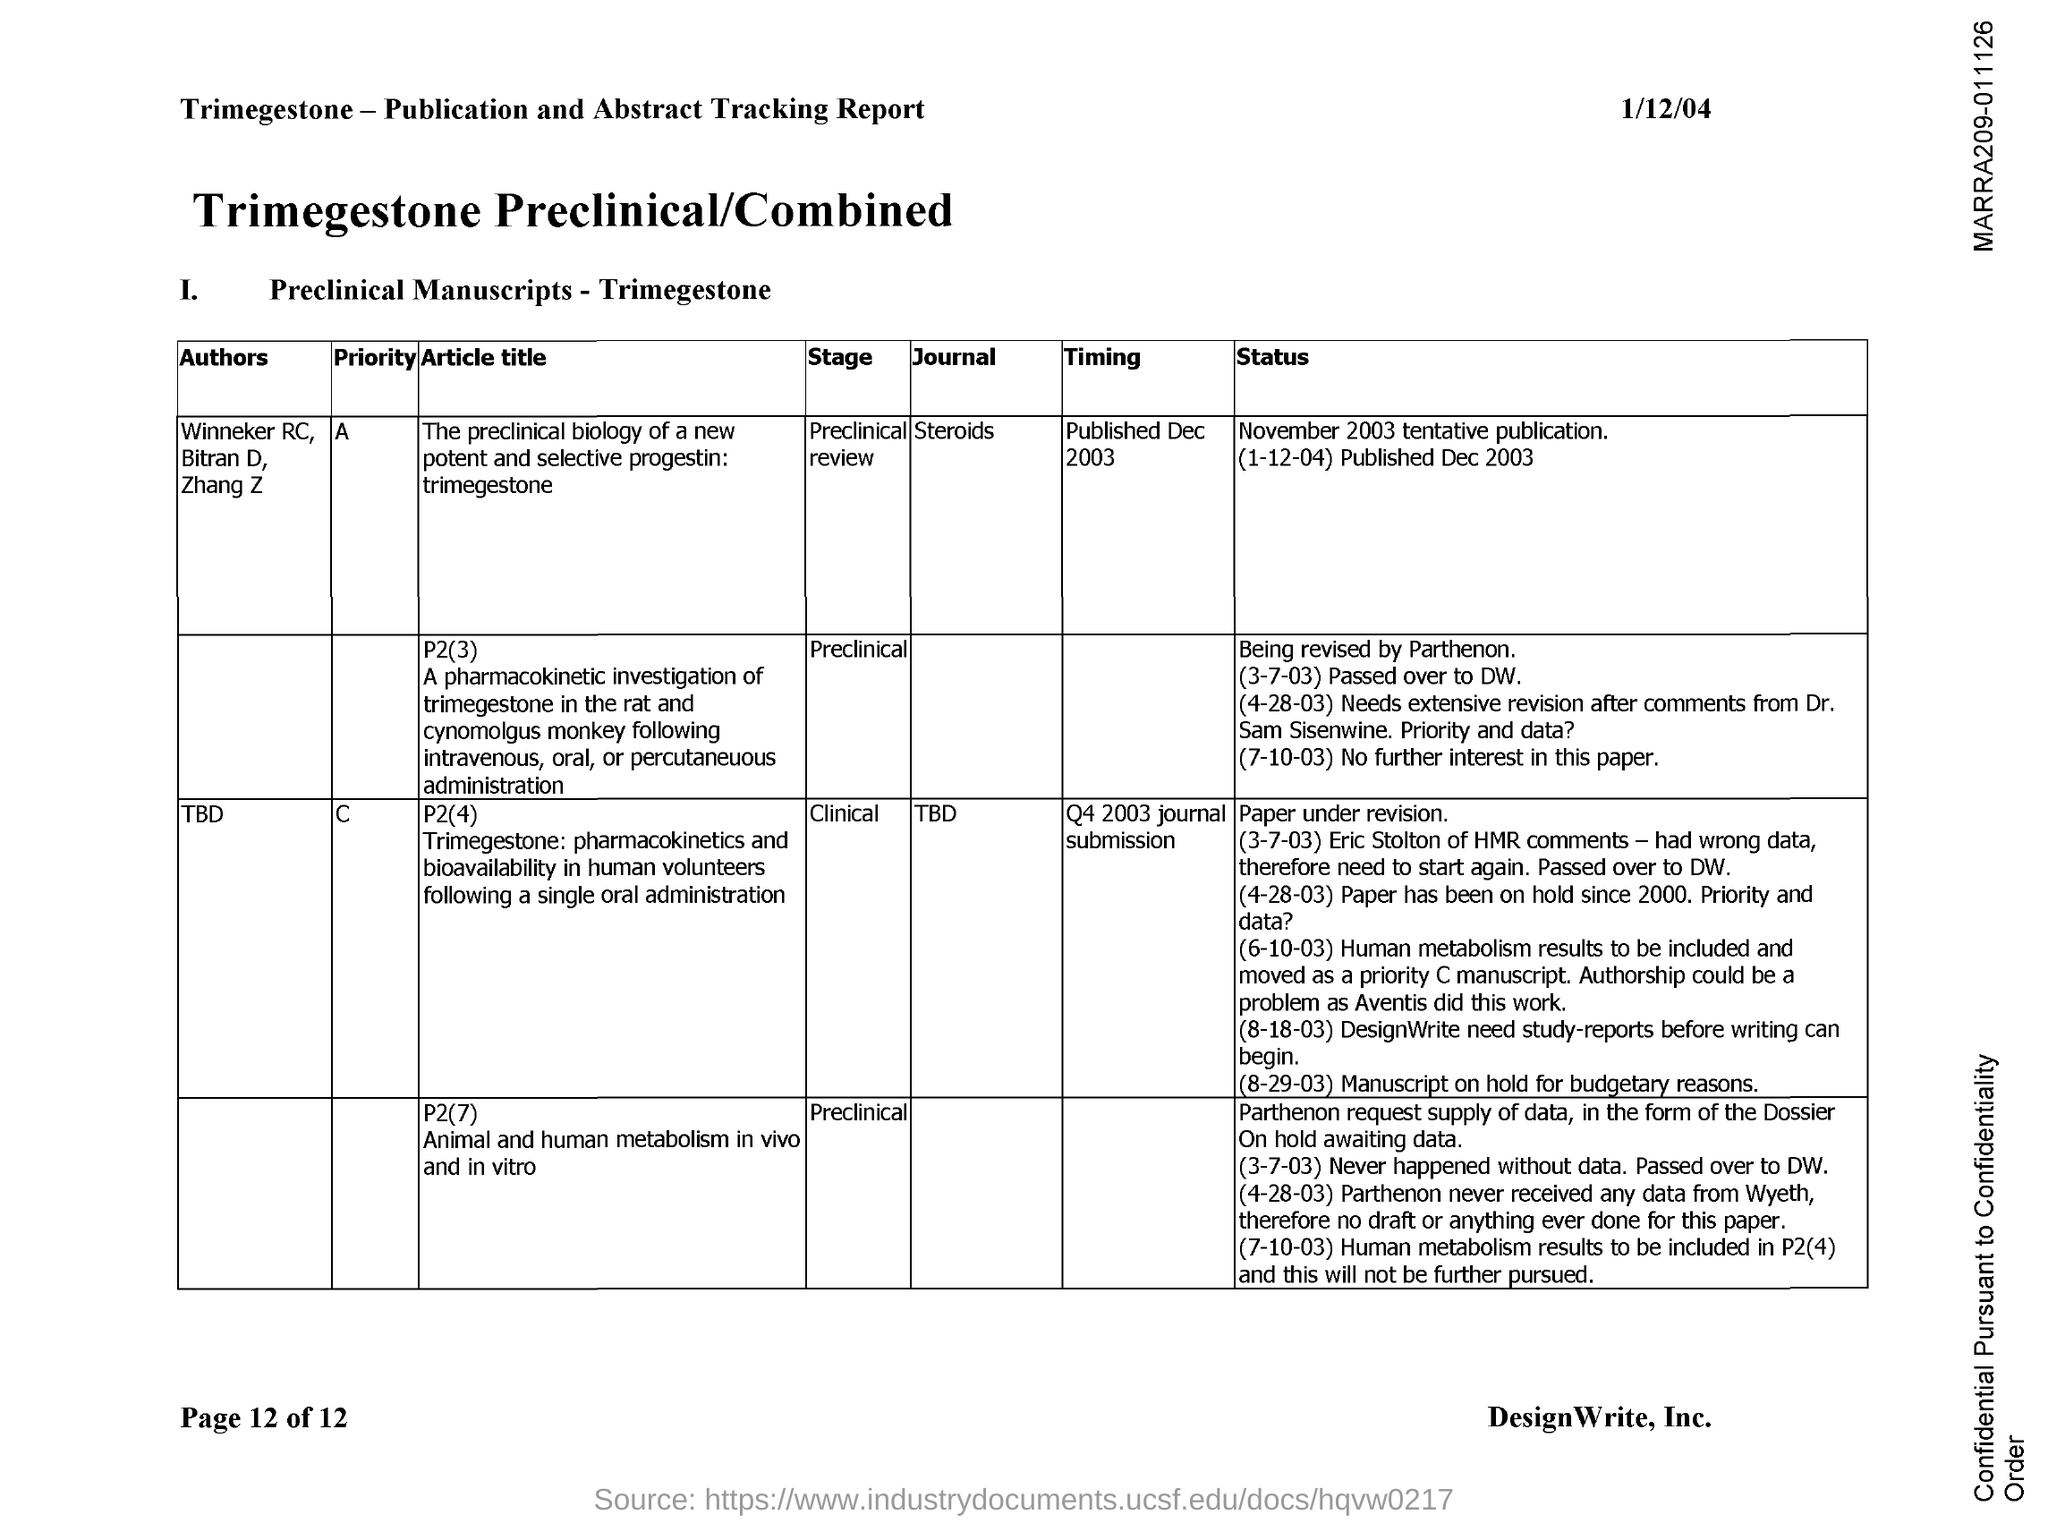Outline some significant characteristics in this image. The article "The preclinical biology of a new potent and selective progestin: trimegestone" was published in the journal Steroids. The article "The preclinical biology of a new potent and selective progestin: trimegestone," which was published in December 2003, provides information on the timing of the article's publication. The preclinical biology of the new potent and selective progestin, trimegestone, is being reviewed in a preclinical review stage. 